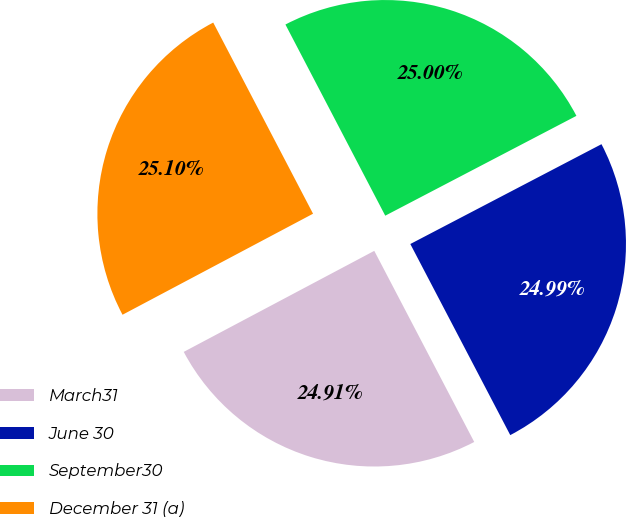<chart> <loc_0><loc_0><loc_500><loc_500><pie_chart><fcel>March31<fcel>June 30<fcel>September30<fcel>December 31 (a)<nl><fcel>24.91%<fcel>24.99%<fcel>25.0%<fcel>25.1%<nl></chart> 